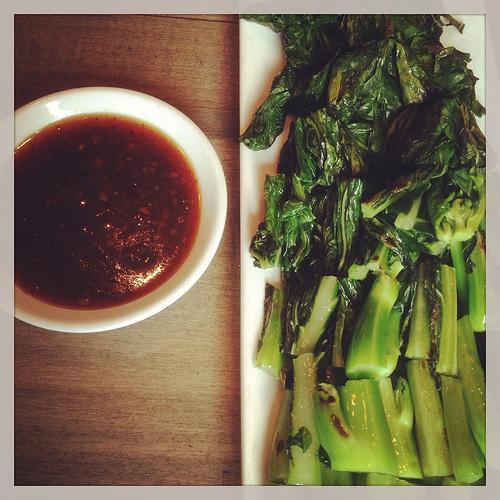How many plates are there?
Give a very brief answer. 1. 